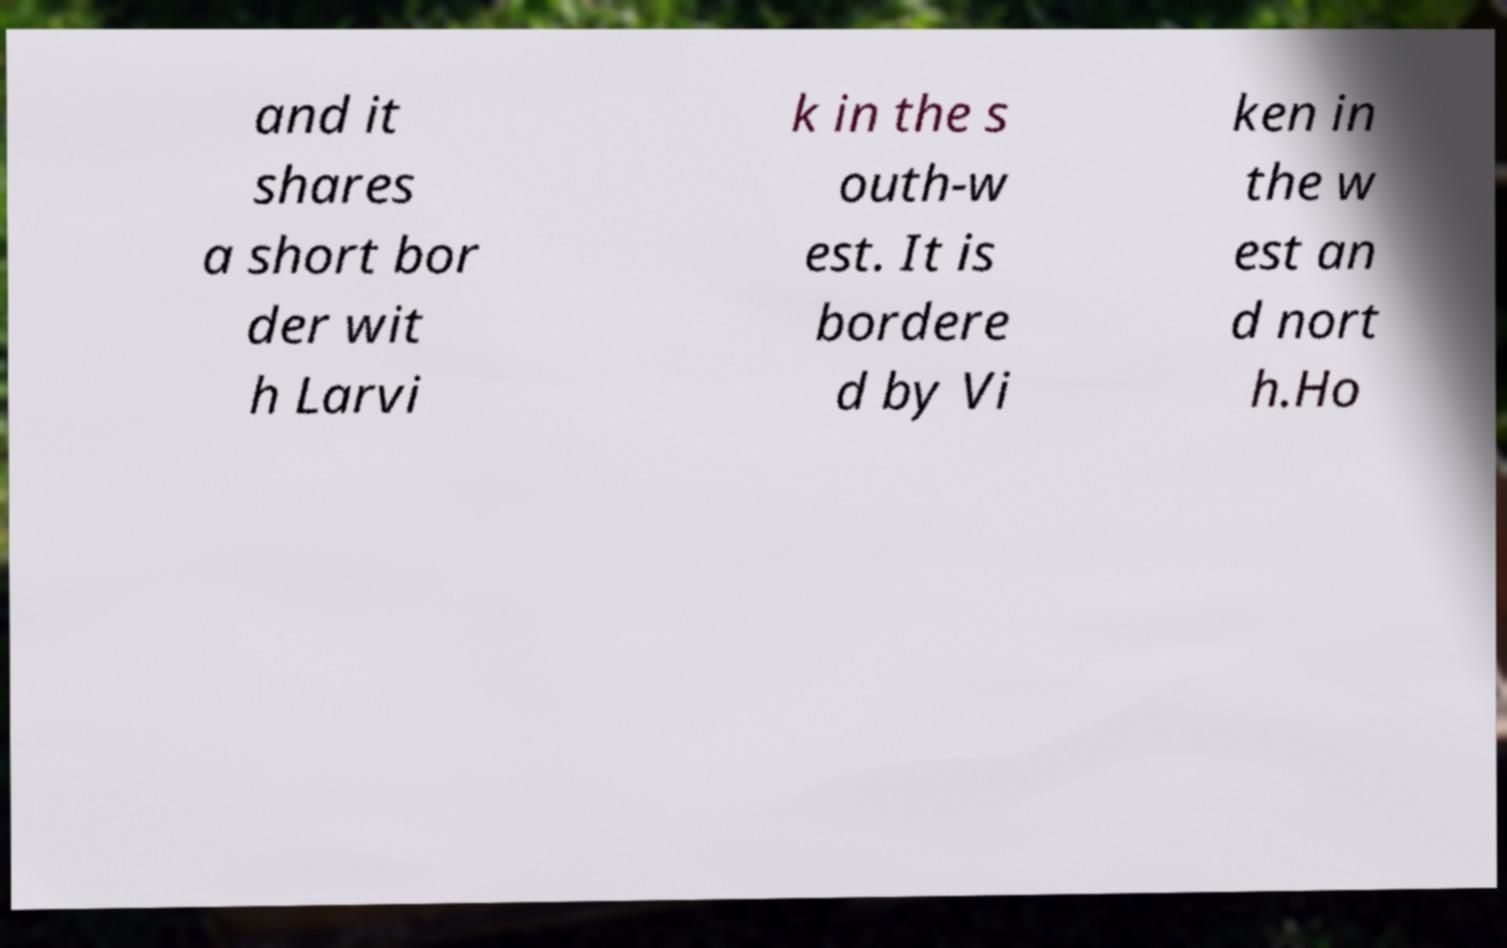Could you extract and type out the text from this image? and it shares a short bor der wit h Larvi k in the s outh-w est. It is bordere d by Vi ken in the w est an d nort h.Ho 